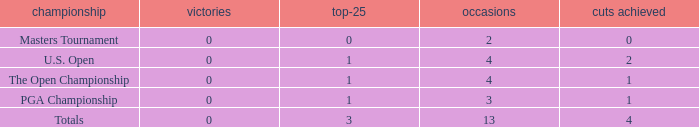How many cuts did he make in the tournament with 3 top 25s and under 13 events? None. 